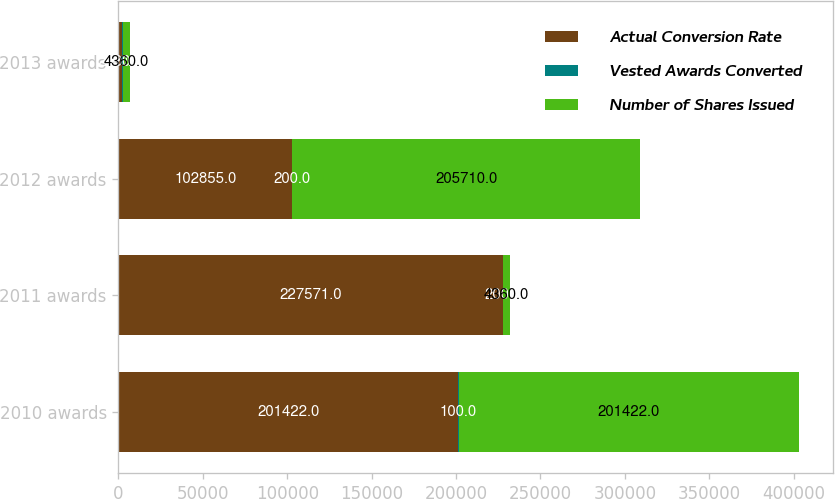<chart> <loc_0><loc_0><loc_500><loc_500><stacked_bar_chart><ecel><fcel>2010 awards<fcel>2011 awards<fcel>2012 awards<fcel>2013 awards<nl><fcel>Actual Conversion Rate<fcel>201422<fcel>227571<fcel>102855<fcel>2180<nl><fcel>Vested Awards Converted<fcel>100<fcel>200<fcel>200<fcel>200<nl><fcel>Number of Shares Issued<fcel>201422<fcel>4360<fcel>205710<fcel>4360<nl></chart> 